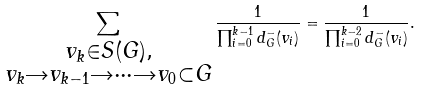<formula> <loc_0><loc_0><loc_500><loc_500>\sum _ { \substack { v _ { k } \in S ( G ) , \\ v _ { k } \rightarrow v _ { k - 1 } \rightarrow \cdots \rightarrow v _ { 0 } \subset G } } \frac { 1 } { \prod _ { i = 0 } ^ { k - 1 } d _ { G } ^ { - } ( v _ { i } ) } = \frac { 1 } { \prod _ { i = 0 } ^ { k - 2 } d _ { G } ^ { - } ( v _ { i } ) } .</formula> 